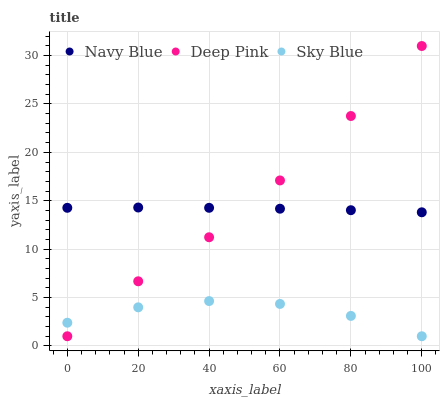Does Sky Blue have the minimum area under the curve?
Answer yes or no. Yes. Does Deep Pink have the maximum area under the curve?
Answer yes or no. Yes. Does Deep Pink have the minimum area under the curve?
Answer yes or no. No. Does Sky Blue have the maximum area under the curve?
Answer yes or no. No. Is Navy Blue the smoothest?
Answer yes or no. Yes. Is Deep Pink the roughest?
Answer yes or no. Yes. Is Sky Blue the smoothest?
Answer yes or no. No. Is Sky Blue the roughest?
Answer yes or no. No. Does Deep Pink have the lowest value?
Answer yes or no. Yes. Does Deep Pink have the highest value?
Answer yes or no. Yes. Does Sky Blue have the highest value?
Answer yes or no. No. Is Sky Blue less than Navy Blue?
Answer yes or no. Yes. Is Navy Blue greater than Sky Blue?
Answer yes or no. Yes. Does Navy Blue intersect Deep Pink?
Answer yes or no. Yes. Is Navy Blue less than Deep Pink?
Answer yes or no. No. Is Navy Blue greater than Deep Pink?
Answer yes or no. No. Does Sky Blue intersect Navy Blue?
Answer yes or no. No. 